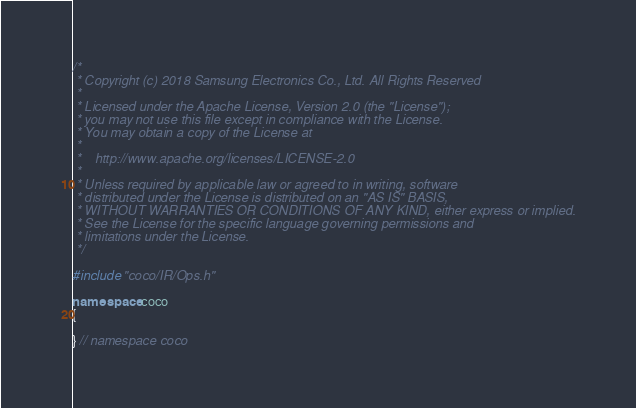<code> <loc_0><loc_0><loc_500><loc_500><_C++_>/*
 * Copyright (c) 2018 Samsung Electronics Co., Ltd. All Rights Reserved
 *
 * Licensed under the Apache License, Version 2.0 (the "License");
 * you may not use this file except in compliance with the License.
 * You may obtain a copy of the License at
 *
 *    http://www.apache.org/licenses/LICENSE-2.0
 *
 * Unless required by applicable law or agreed to in writing, software
 * distributed under the License is distributed on an "AS IS" BASIS,
 * WITHOUT WARRANTIES OR CONDITIONS OF ANY KIND, either express or implied.
 * See the License for the specific language governing permissions and
 * limitations under the License.
 */

#include "coco/IR/Ops.h"

namespace coco
{

} // namespace coco
</code> 